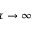Convert formula to latex. <formula><loc_0><loc_0><loc_500><loc_500>\tau \to \infty</formula> 